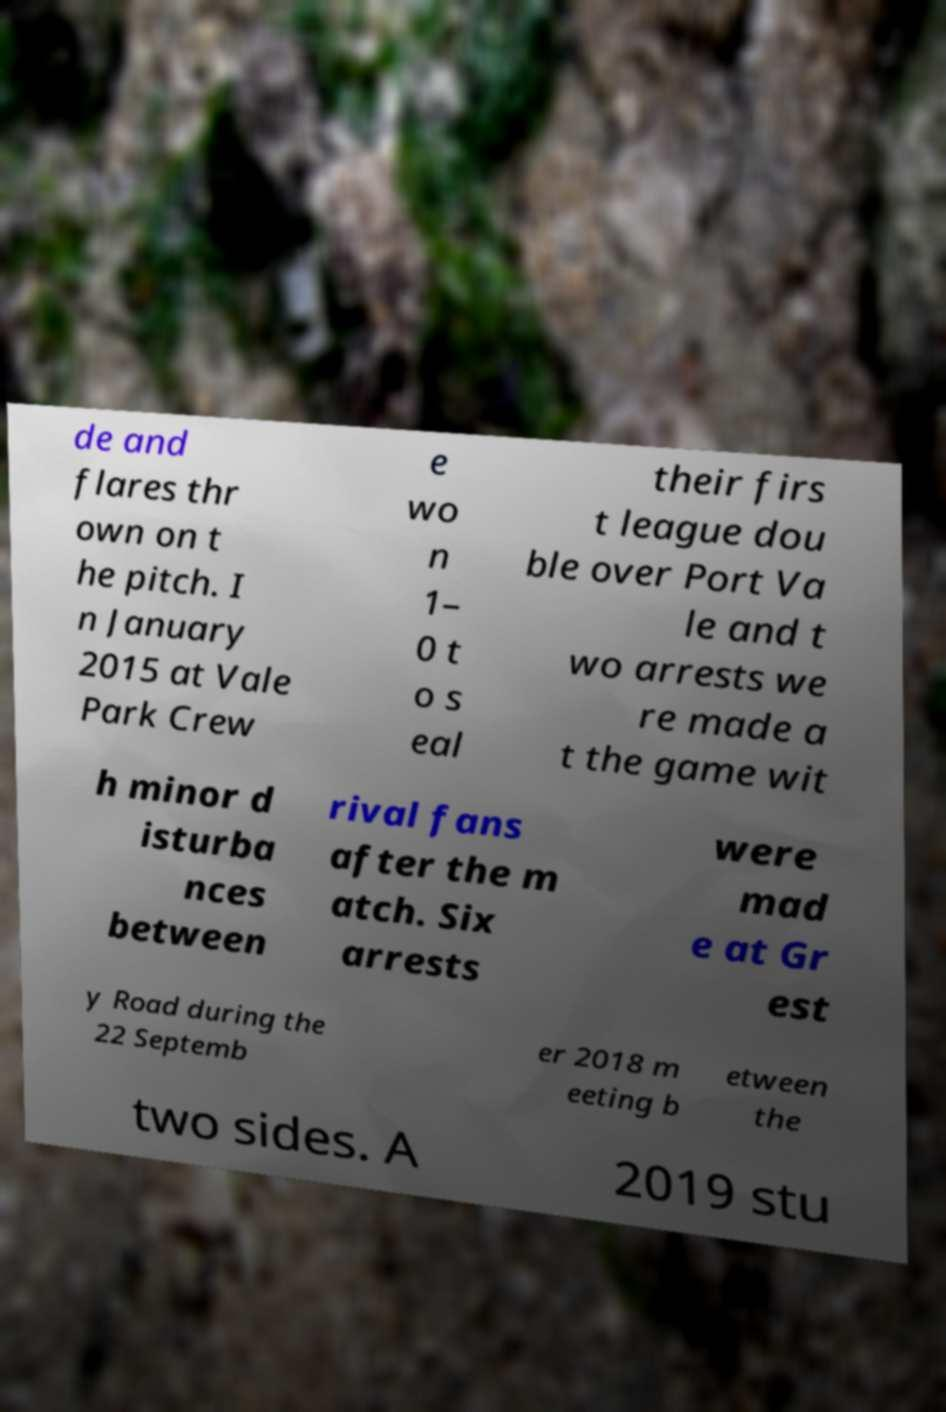Please read and relay the text visible in this image. What does it say? de and flares thr own on t he pitch. I n January 2015 at Vale Park Crew e wo n 1– 0 t o s eal their firs t league dou ble over Port Va le and t wo arrests we re made a t the game wit h minor d isturba nces between rival fans after the m atch. Six arrests were mad e at Gr est y Road during the 22 Septemb er 2018 m eeting b etween the two sides. A 2019 stu 